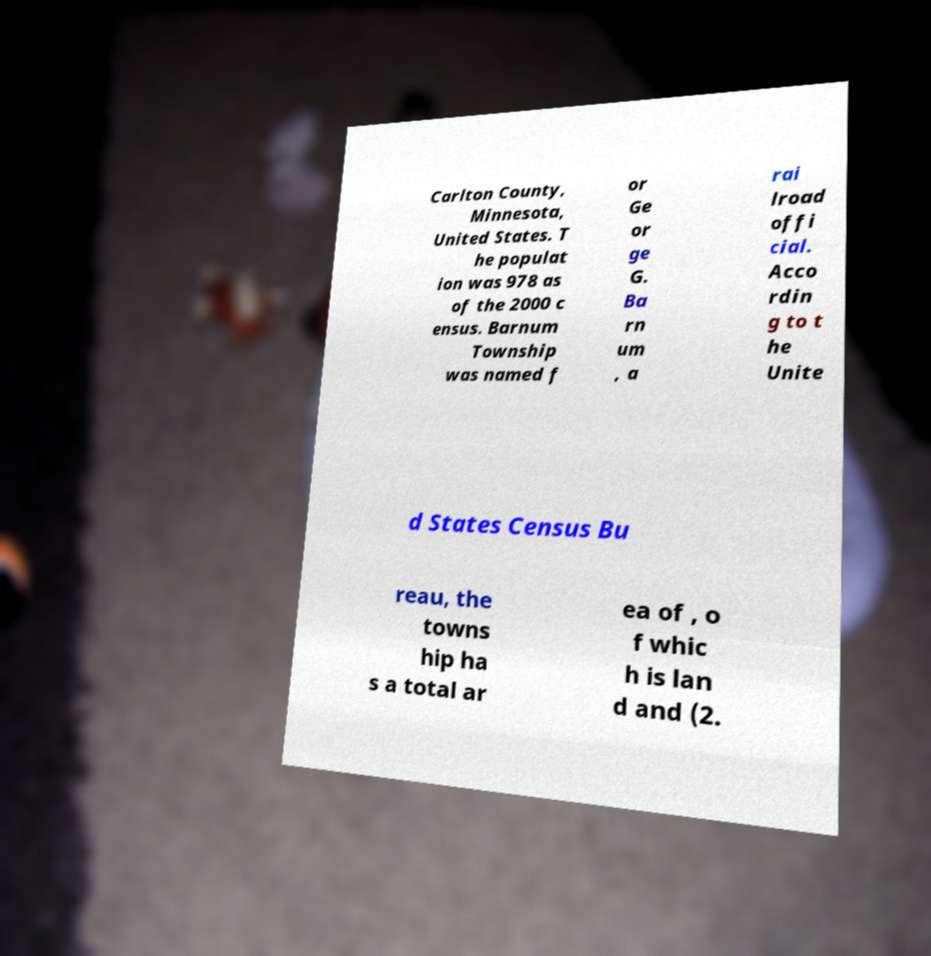Please read and relay the text visible in this image. What does it say? Carlton County, Minnesota, United States. T he populat ion was 978 as of the 2000 c ensus. Barnum Township was named f or Ge or ge G. Ba rn um , a rai lroad offi cial. Acco rdin g to t he Unite d States Census Bu reau, the towns hip ha s a total ar ea of , o f whic h is lan d and (2. 